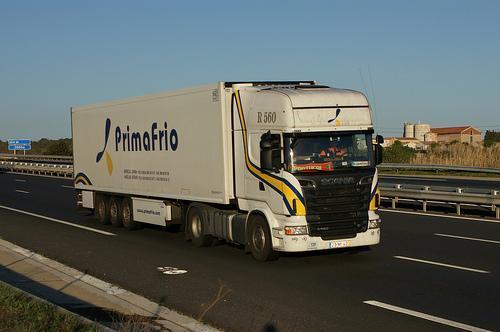How many wheels are on the right side of the truck?
Give a very brief answer. 5. How many people are in the cab of the truck?
Give a very brief answer. 1. 